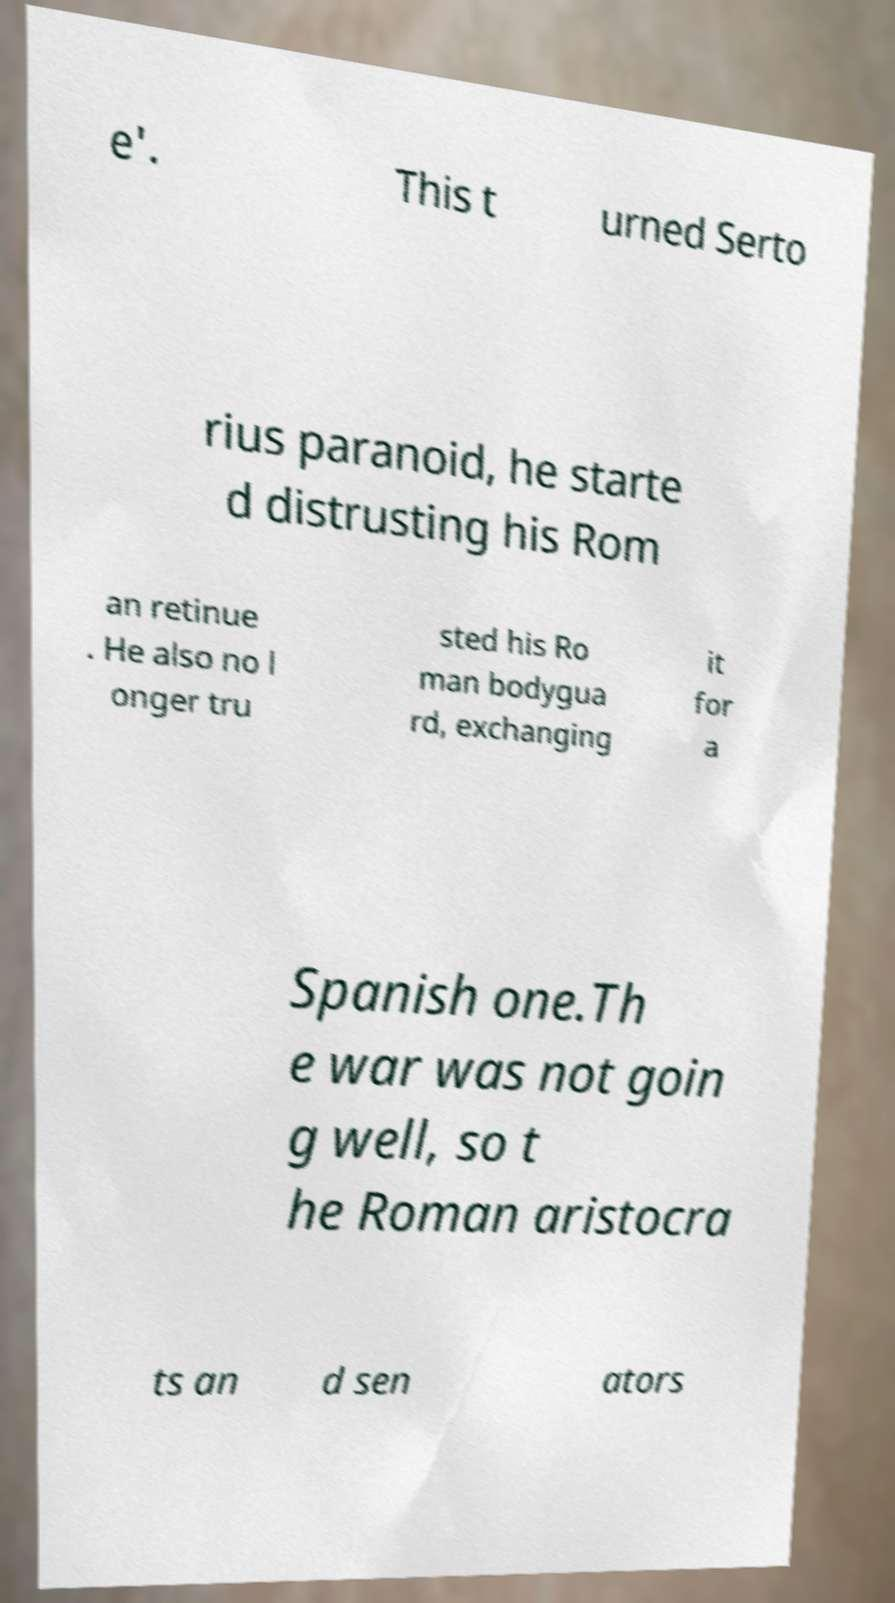Please read and relay the text visible in this image. What does it say? e'. This t urned Serto rius paranoid, he starte d distrusting his Rom an retinue . He also no l onger tru sted his Ro man bodygua rd, exchanging it for a Spanish one.Th e war was not goin g well, so t he Roman aristocra ts an d sen ators 